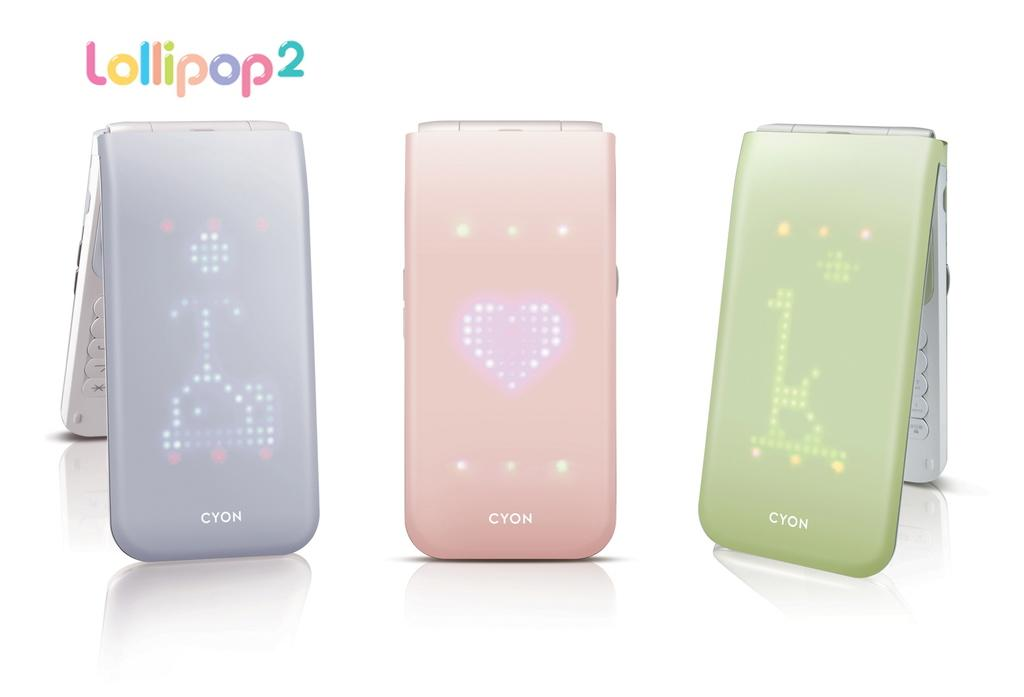Provide a one-sentence caption for the provided image. Purple, pink, and green Lollipop2 are standing side by side. . 